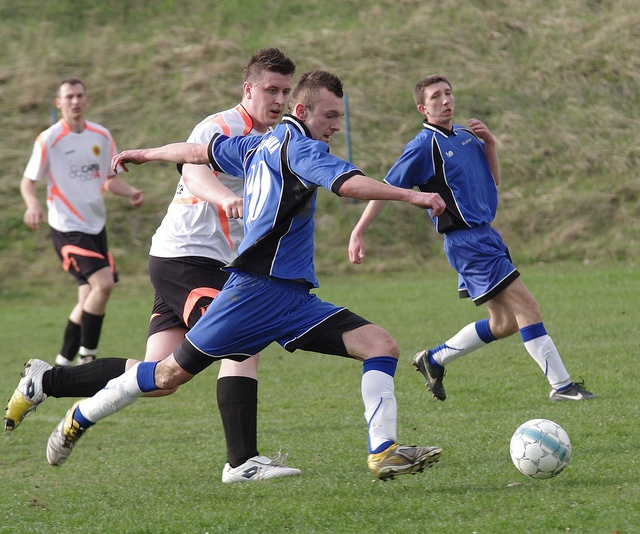Describe the objects in this image and their specific colors. I can see people in olive, black, navy, lightgray, and darkgray tones, people in olive, black, lightgray, darkgray, and gray tones, people in olive, navy, gray, and black tones, people in olive, darkgray, black, and lightgray tones, and sports ball in olive, lightgray, darkgray, and gray tones in this image. 